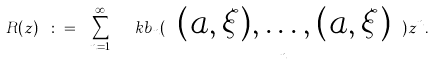Convert formula to latex. <formula><loc_0><loc_0><loc_500><loc_500>R ( z ) \ \colon = \ \sum _ { n = 1 } ^ { \infty } \ \ k b _ { n } ( \ \underbrace { ( a , \xi ) , \dots , ( a , \xi ) } _ { n } \ ) z ^ { n } .</formula> 